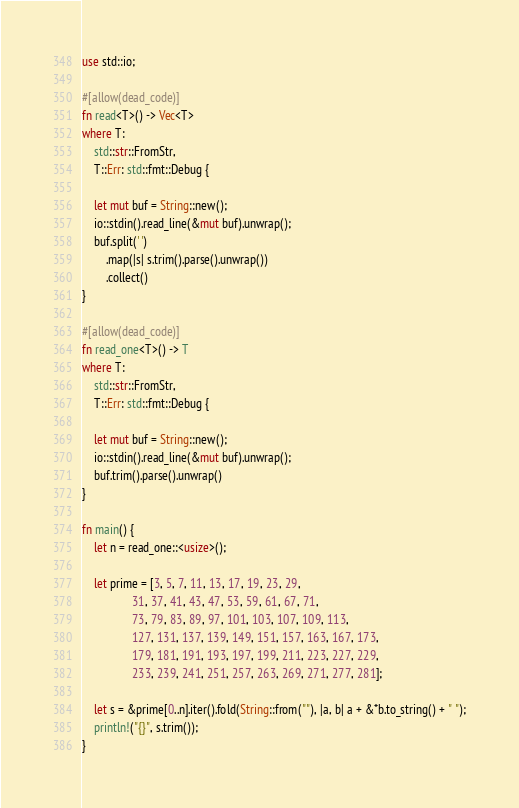Convert code to text. <code><loc_0><loc_0><loc_500><loc_500><_Rust_>use std::io;

#[allow(dead_code)]
fn read<T>() -> Vec<T>
where T:
    std::str::FromStr,
    T::Err: std::fmt::Debug {

    let mut buf = String::new();
    io::stdin().read_line(&mut buf).unwrap();
    buf.split(' ')
        .map(|s| s.trim().parse().unwrap())
        .collect()
}

#[allow(dead_code)]
fn read_one<T>() -> T
where T:
    std::str::FromStr,
    T::Err: std::fmt::Debug {

    let mut buf = String::new();
    io::stdin().read_line(&mut buf).unwrap();
    buf.trim().parse().unwrap()
}

fn main() {
    let n = read_one::<usize>();

    let prime = [3, 5, 7, 11, 13, 17, 19, 23, 29,
                 31, 37, 41, 43, 47, 53, 59, 61, 67, 71,
                 73, 79, 83, 89, 97, 101, 103, 107, 109, 113,
                 127, 131, 137, 139, 149, 151, 157, 163, 167, 173,
                 179, 181, 191, 193, 197, 199, 211, 223, 227, 229,
                 233, 239, 241, 251, 257, 263, 269, 271, 277, 281];

    let s = &prime[0..n].iter().fold(String::from(""), |a, b| a + &*b.to_string() + " ");
    println!("{}", s.trim());
}</code> 